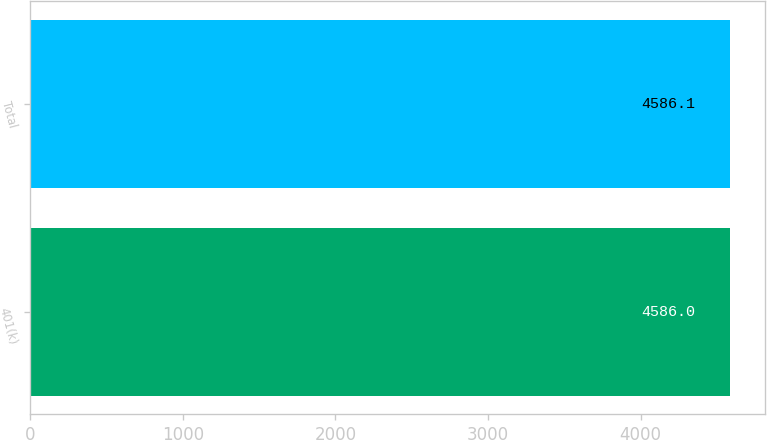Convert chart to OTSL. <chart><loc_0><loc_0><loc_500><loc_500><bar_chart><fcel>401(k)<fcel>Total<nl><fcel>4586<fcel>4586.1<nl></chart> 